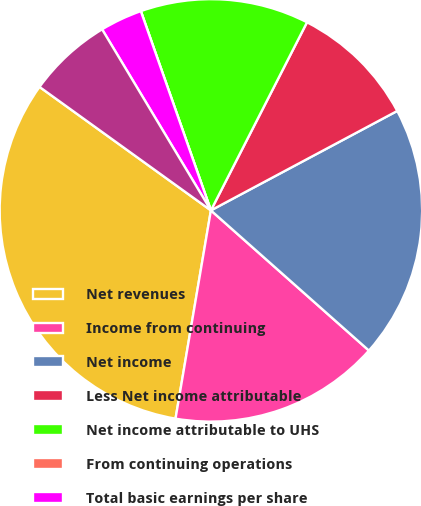<chart> <loc_0><loc_0><loc_500><loc_500><pie_chart><fcel>Net revenues<fcel>Income from continuing<fcel>Net income<fcel>Less Net income attributable<fcel>Net income attributable to UHS<fcel>From continuing operations<fcel>Total basic earnings per share<fcel>Total diluted earnings per<nl><fcel>32.26%<fcel>16.13%<fcel>19.35%<fcel>9.68%<fcel>12.9%<fcel>0.0%<fcel>3.23%<fcel>6.45%<nl></chart> 